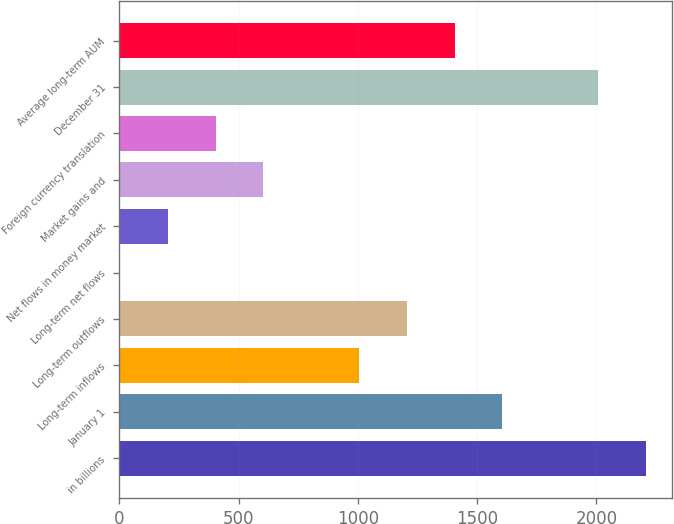<chart> <loc_0><loc_0><loc_500><loc_500><bar_chart><fcel>in billions<fcel>January 1<fcel>Long-term inflows<fcel>Long-term outflows<fcel>Long-term net flows<fcel>Net flows in money market<fcel>Market gains and<fcel>Foreign currency translation<fcel>December 31<fcel>Average long-term AUM<nl><fcel>2207.36<fcel>1606.28<fcel>1005.2<fcel>1205.56<fcel>3.4<fcel>203.76<fcel>604.48<fcel>404.12<fcel>2007<fcel>1405.92<nl></chart> 